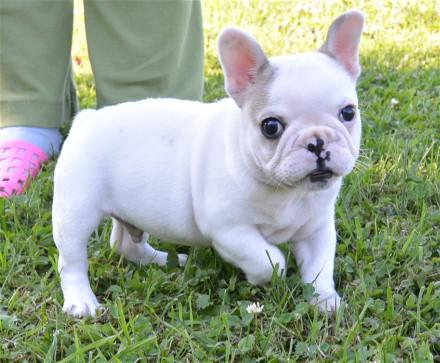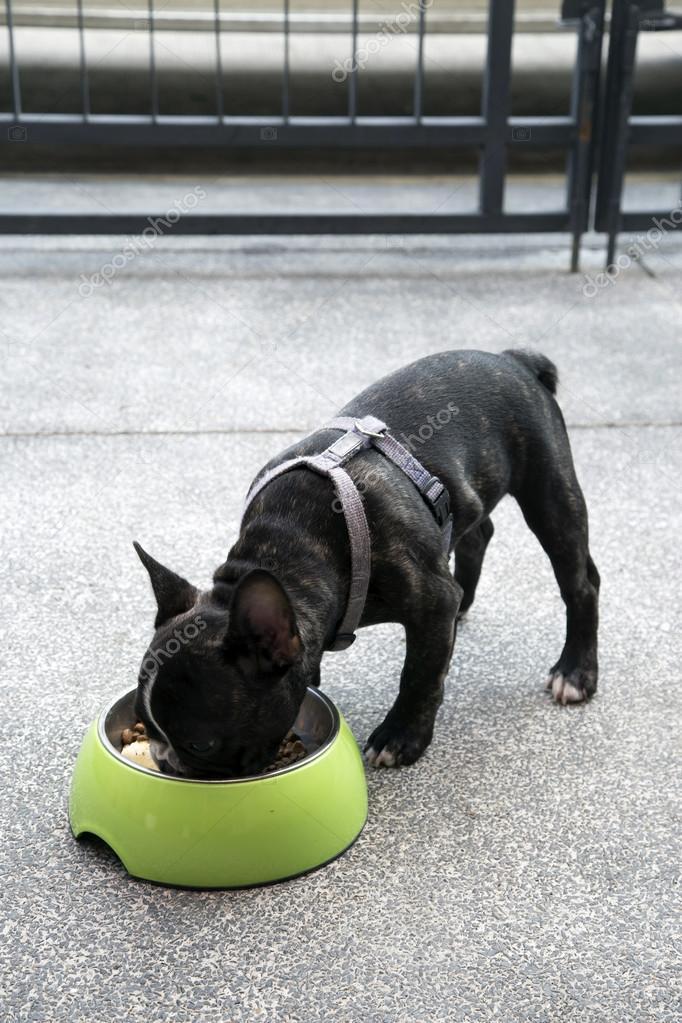The first image is the image on the left, the second image is the image on the right. Given the left and right images, does the statement "In at least one image ther is a small black puppy in a grey harness eating out of a green bowl." hold true? Answer yes or no. Yes. The first image is the image on the left, the second image is the image on the right. Considering the images on both sides, is "Each image shows a dog with a food bowl in front of it." valid? Answer yes or no. No. 